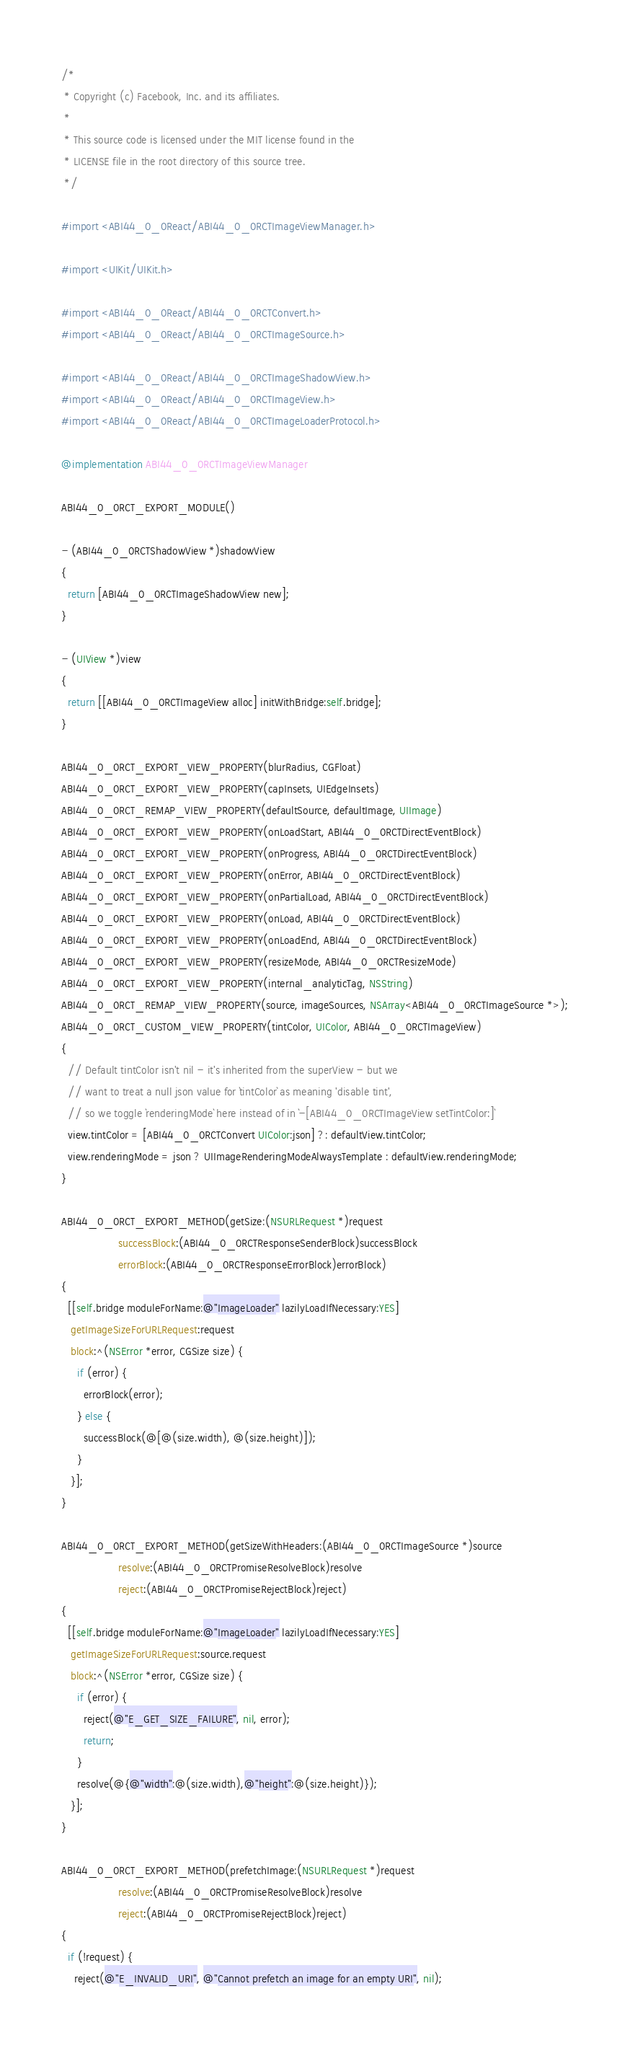<code> <loc_0><loc_0><loc_500><loc_500><_ObjectiveC_>/*
 * Copyright (c) Facebook, Inc. and its affiliates.
 *
 * This source code is licensed under the MIT license found in the
 * LICENSE file in the root directory of this source tree.
 */

#import <ABI44_0_0React/ABI44_0_0RCTImageViewManager.h>

#import <UIKit/UIKit.h>

#import <ABI44_0_0React/ABI44_0_0RCTConvert.h>
#import <ABI44_0_0React/ABI44_0_0RCTImageSource.h>

#import <ABI44_0_0React/ABI44_0_0RCTImageShadowView.h>
#import <ABI44_0_0React/ABI44_0_0RCTImageView.h>
#import <ABI44_0_0React/ABI44_0_0RCTImageLoaderProtocol.h>

@implementation ABI44_0_0RCTImageViewManager

ABI44_0_0RCT_EXPORT_MODULE()

- (ABI44_0_0RCTShadowView *)shadowView
{
  return [ABI44_0_0RCTImageShadowView new];
}

- (UIView *)view
{
  return [[ABI44_0_0RCTImageView alloc] initWithBridge:self.bridge];
}

ABI44_0_0RCT_EXPORT_VIEW_PROPERTY(blurRadius, CGFloat)
ABI44_0_0RCT_EXPORT_VIEW_PROPERTY(capInsets, UIEdgeInsets)
ABI44_0_0RCT_REMAP_VIEW_PROPERTY(defaultSource, defaultImage, UIImage)
ABI44_0_0RCT_EXPORT_VIEW_PROPERTY(onLoadStart, ABI44_0_0RCTDirectEventBlock)
ABI44_0_0RCT_EXPORT_VIEW_PROPERTY(onProgress, ABI44_0_0RCTDirectEventBlock)
ABI44_0_0RCT_EXPORT_VIEW_PROPERTY(onError, ABI44_0_0RCTDirectEventBlock)
ABI44_0_0RCT_EXPORT_VIEW_PROPERTY(onPartialLoad, ABI44_0_0RCTDirectEventBlock)
ABI44_0_0RCT_EXPORT_VIEW_PROPERTY(onLoad, ABI44_0_0RCTDirectEventBlock)
ABI44_0_0RCT_EXPORT_VIEW_PROPERTY(onLoadEnd, ABI44_0_0RCTDirectEventBlock)
ABI44_0_0RCT_EXPORT_VIEW_PROPERTY(resizeMode, ABI44_0_0RCTResizeMode)
ABI44_0_0RCT_EXPORT_VIEW_PROPERTY(internal_analyticTag, NSString)
ABI44_0_0RCT_REMAP_VIEW_PROPERTY(source, imageSources, NSArray<ABI44_0_0RCTImageSource *>);
ABI44_0_0RCT_CUSTOM_VIEW_PROPERTY(tintColor, UIColor, ABI44_0_0RCTImageView)
{
  // Default tintColor isn't nil - it's inherited from the superView - but we
  // want to treat a null json value for `tintColor` as meaning 'disable tint',
  // so we toggle `renderingMode` here instead of in `-[ABI44_0_0RCTImageView setTintColor:]`
  view.tintColor = [ABI44_0_0RCTConvert UIColor:json] ?: defaultView.tintColor;
  view.renderingMode = json ? UIImageRenderingModeAlwaysTemplate : defaultView.renderingMode;
}

ABI44_0_0RCT_EXPORT_METHOD(getSize:(NSURLRequest *)request
                  successBlock:(ABI44_0_0RCTResponseSenderBlock)successBlock
                  errorBlock:(ABI44_0_0RCTResponseErrorBlock)errorBlock)
{
  [[self.bridge moduleForName:@"ImageLoader" lazilyLoadIfNecessary:YES]
   getImageSizeForURLRequest:request
   block:^(NSError *error, CGSize size) {
     if (error) {
       errorBlock(error);
     } else {
       successBlock(@[@(size.width), @(size.height)]);
     }
   }];
}

ABI44_0_0RCT_EXPORT_METHOD(getSizeWithHeaders:(ABI44_0_0RCTImageSource *)source
                  resolve:(ABI44_0_0RCTPromiseResolveBlock)resolve
                  reject:(ABI44_0_0RCTPromiseRejectBlock)reject)
{
  [[self.bridge moduleForName:@"ImageLoader" lazilyLoadIfNecessary:YES]
   getImageSizeForURLRequest:source.request
   block:^(NSError *error, CGSize size) {
     if (error) {
       reject(@"E_GET_SIZE_FAILURE", nil, error);
       return;
     }
     resolve(@{@"width":@(size.width),@"height":@(size.height)});
   }];
}

ABI44_0_0RCT_EXPORT_METHOD(prefetchImage:(NSURLRequest *)request
                  resolve:(ABI44_0_0RCTPromiseResolveBlock)resolve
                  reject:(ABI44_0_0RCTPromiseRejectBlock)reject)
{
  if (!request) {
    reject(@"E_INVALID_URI", @"Cannot prefetch an image for an empty URI", nil);</code> 